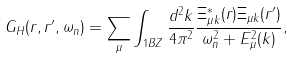Convert formula to latex. <formula><loc_0><loc_0><loc_500><loc_500>G _ { H } ( { r } , { r } ^ { \prime } , \omega _ { n } ) = \sum _ { \mu } \int _ { 1 B Z } \frac { d ^ { 2 } k } { 4 \pi ^ { 2 } } \frac { \Xi _ { \mu { k } } ^ { \ast } ( { r } ) \Xi _ { \mu { k } } ( { r } ^ { \prime } ) } { \omega _ { n } ^ { 2 } + E _ { \mu } ^ { 2 } ( { k } ) } ,</formula> 